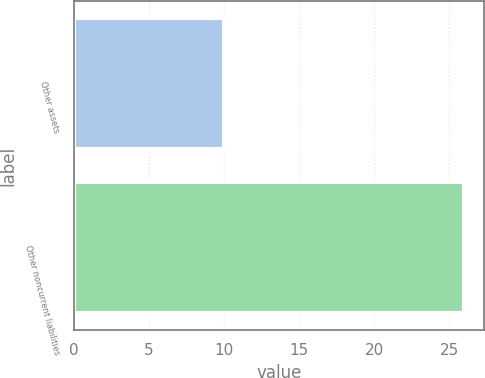Convert chart. <chart><loc_0><loc_0><loc_500><loc_500><bar_chart><fcel>Other assets<fcel>Other noncurrent liabilities<nl><fcel>10<fcel>26<nl></chart> 